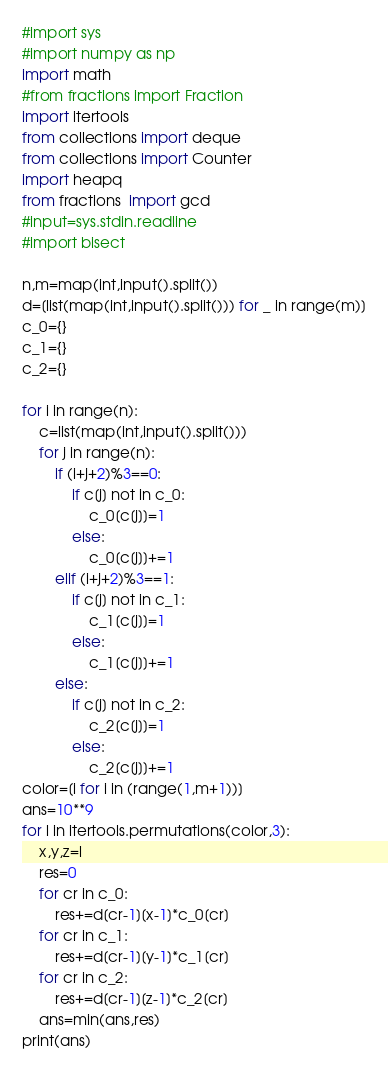Convert code to text. <code><loc_0><loc_0><loc_500><loc_500><_Python_>#import sys
#import numpy as np
import math
#from fractions import Fraction
import itertools
from collections import deque
from collections import Counter
import heapq
from fractions  import gcd
#input=sys.stdin.readline
#import bisect

n,m=map(int,input().split())
d=[list(map(int,input().split())) for _ in range(m)]
c_0={}
c_1={}
c_2={}

for i in range(n):
    c=list(map(int,input().split()))
    for j in range(n):
        if (i+j+2)%3==0:
            if c[j] not in c_0:
                c_0[c[j]]=1
            else:
                c_0[c[j]]+=1
        elif (i+j+2)%3==1:
            if c[j] not in c_1:
                c_1[c[j]]=1
            else:
                c_1[c[j]]+=1
        else:
            if c[j] not in c_2:
                c_2[c[j]]=1
            else:
                c_2[c[j]]+=1
color=[i for i in (range(1,m+1))]
ans=10**9
for l in itertools.permutations(color,3):
    x,y,z=l
    res=0
    for cr in c_0:
        res+=d[cr-1][x-1]*c_0[cr]
    for cr in c_1:
        res+=d[cr-1][y-1]*c_1[cr]
    for cr in c_2:
        res+=d[cr-1][z-1]*c_2[cr]
    ans=min(ans,res)
print(ans)</code> 